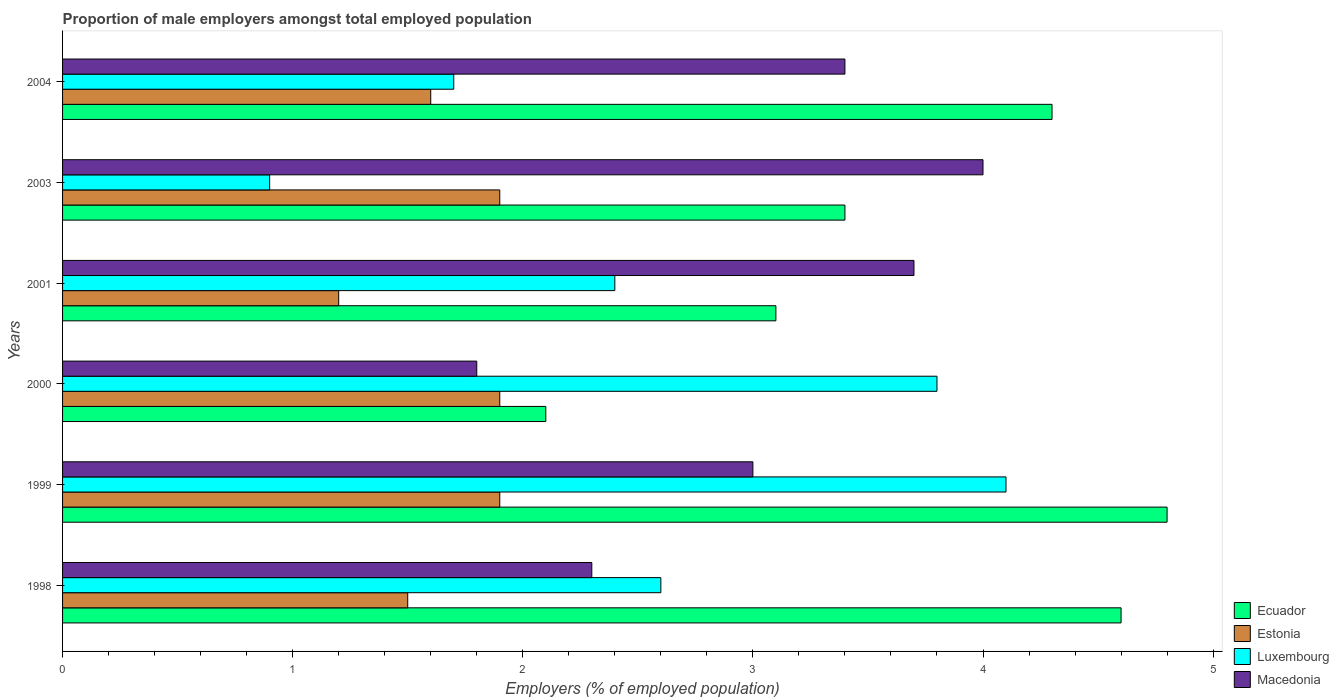How many different coloured bars are there?
Keep it short and to the point. 4. Are the number of bars per tick equal to the number of legend labels?
Provide a succinct answer. Yes. How many bars are there on the 3rd tick from the bottom?
Ensure brevity in your answer.  4. What is the label of the 4th group of bars from the top?
Make the answer very short. 2000. In how many cases, is the number of bars for a given year not equal to the number of legend labels?
Offer a very short reply. 0. What is the proportion of male employers in Estonia in 2001?
Ensure brevity in your answer.  1.2. Across all years, what is the maximum proportion of male employers in Ecuador?
Your answer should be compact. 4.8. Across all years, what is the minimum proportion of male employers in Ecuador?
Keep it short and to the point. 2.1. In which year was the proportion of male employers in Ecuador minimum?
Keep it short and to the point. 2000. What is the total proportion of male employers in Macedonia in the graph?
Offer a terse response. 18.2. What is the difference between the proportion of male employers in Ecuador in 2003 and that in 2004?
Offer a very short reply. -0.9. What is the difference between the proportion of male employers in Ecuador in 2004 and the proportion of male employers in Estonia in 1999?
Make the answer very short. 2.4. What is the average proportion of male employers in Luxembourg per year?
Offer a terse response. 2.58. In the year 2003, what is the difference between the proportion of male employers in Ecuador and proportion of male employers in Luxembourg?
Keep it short and to the point. 2.5. What is the ratio of the proportion of male employers in Ecuador in 1999 to that in 2001?
Your response must be concise. 1.55. Is the proportion of male employers in Ecuador in 1999 less than that in 2003?
Keep it short and to the point. No. What is the difference between the highest and the second highest proportion of male employers in Macedonia?
Ensure brevity in your answer.  0.3. What is the difference between the highest and the lowest proportion of male employers in Luxembourg?
Provide a succinct answer. 3.2. In how many years, is the proportion of male employers in Ecuador greater than the average proportion of male employers in Ecuador taken over all years?
Your answer should be compact. 3. Is the sum of the proportion of male employers in Ecuador in 1998 and 2003 greater than the maximum proportion of male employers in Estonia across all years?
Your response must be concise. Yes. What does the 2nd bar from the top in 2001 represents?
Make the answer very short. Luxembourg. What does the 1st bar from the bottom in 1999 represents?
Make the answer very short. Ecuador. Is it the case that in every year, the sum of the proportion of male employers in Estonia and proportion of male employers in Ecuador is greater than the proportion of male employers in Macedonia?
Give a very brief answer. Yes. How many bars are there?
Ensure brevity in your answer.  24. Are all the bars in the graph horizontal?
Make the answer very short. Yes. How many years are there in the graph?
Your response must be concise. 6. Are the values on the major ticks of X-axis written in scientific E-notation?
Make the answer very short. No. Does the graph contain grids?
Offer a terse response. No. What is the title of the graph?
Ensure brevity in your answer.  Proportion of male employers amongst total employed population. Does "Sint Maarten (Dutch part)" appear as one of the legend labels in the graph?
Make the answer very short. No. What is the label or title of the X-axis?
Your answer should be compact. Employers (% of employed population). What is the label or title of the Y-axis?
Your answer should be very brief. Years. What is the Employers (% of employed population) of Ecuador in 1998?
Make the answer very short. 4.6. What is the Employers (% of employed population) in Luxembourg in 1998?
Your answer should be very brief. 2.6. What is the Employers (% of employed population) of Macedonia in 1998?
Offer a terse response. 2.3. What is the Employers (% of employed population) in Ecuador in 1999?
Make the answer very short. 4.8. What is the Employers (% of employed population) of Estonia in 1999?
Offer a very short reply. 1.9. What is the Employers (% of employed population) of Luxembourg in 1999?
Provide a succinct answer. 4.1. What is the Employers (% of employed population) of Macedonia in 1999?
Your answer should be very brief. 3. What is the Employers (% of employed population) of Ecuador in 2000?
Your answer should be very brief. 2.1. What is the Employers (% of employed population) of Estonia in 2000?
Provide a succinct answer. 1.9. What is the Employers (% of employed population) of Luxembourg in 2000?
Your answer should be very brief. 3.8. What is the Employers (% of employed population) in Macedonia in 2000?
Give a very brief answer. 1.8. What is the Employers (% of employed population) of Ecuador in 2001?
Give a very brief answer. 3.1. What is the Employers (% of employed population) of Estonia in 2001?
Ensure brevity in your answer.  1.2. What is the Employers (% of employed population) in Luxembourg in 2001?
Your response must be concise. 2.4. What is the Employers (% of employed population) of Macedonia in 2001?
Offer a very short reply. 3.7. What is the Employers (% of employed population) in Ecuador in 2003?
Keep it short and to the point. 3.4. What is the Employers (% of employed population) in Estonia in 2003?
Offer a very short reply. 1.9. What is the Employers (% of employed population) of Luxembourg in 2003?
Offer a terse response. 0.9. What is the Employers (% of employed population) of Macedonia in 2003?
Ensure brevity in your answer.  4. What is the Employers (% of employed population) in Ecuador in 2004?
Provide a succinct answer. 4.3. What is the Employers (% of employed population) of Estonia in 2004?
Keep it short and to the point. 1.6. What is the Employers (% of employed population) of Luxembourg in 2004?
Your response must be concise. 1.7. What is the Employers (% of employed population) in Macedonia in 2004?
Ensure brevity in your answer.  3.4. Across all years, what is the maximum Employers (% of employed population) of Ecuador?
Offer a terse response. 4.8. Across all years, what is the maximum Employers (% of employed population) in Estonia?
Provide a succinct answer. 1.9. Across all years, what is the maximum Employers (% of employed population) of Luxembourg?
Your answer should be compact. 4.1. Across all years, what is the maximum Employers (% of employed population) of Macedonia?
Keep it short and to the point. 4. Across all years, what is the minimum Employers (% of employed population) of Ecuador?
Your answer should be very brief. 2.1. Across all years, what is the minimum Employers (% of employed population) of Estonia?
Give a very brief answer. 1.2. Across all years, what is the minimum Employers (% of employed population) in Luxembourg?
Make the answer very short. 0.9. Across all years, what is the minimum Employers (% of employed population) in Macedonia?
Make the answer very short. 1.8. What is the total Employers (% of employed population) of Ecuador in the graph?
Your response must be concise. 22.3. What is the total Employers (% of employed population) in Estonia in the graph?
Keep it short and to the point. 10. What is the total Employers (% of employed population) of Macedonia in the graph?
Your answer should be very brief. 18.2. What is the difference between the Employers (% of employed population) in Estonia in 1998 and that in 1999?
Your answer should be very brief. -0.4. What is the difference between the Employers (% of employed population) of Luxembourg in 1998 and that in 1999?
Offer a terse response. -1.5. What is the difference between the Employers (% of employed population) in Macedonia in 1998 and that in 1999?
Give a very brief answer. -0.7. What is the difference between the Employers (% of employed population) in Ecuador in 1998 and that in 2000?
Provide a succinct answer. 2.5. What is the difference between the Employers (% of employed population) of Ecuador in 1998 and that in 2001?
Ensure brevity in your answer.  1.5. What is the difference between the Employers (% of employed population) in Estonia in 1998 and that in 2001?
Your answer should be compact. 0.3. What is the difference between the Employers (% of employed population) in Luxembourg in 1998 and that in 2001?
Your response must be concise. 0.2. What is the difference between the Employers (% of employed population) of Ecuador in 1998 and that in 2003?
Your response must be concise. 1.2. What is the difference between the Employers (% of employed population) of Estonia in 1998 and that in 2003?
Keep it short and to the point. -0.4. What is the difference between the Employers (% of employed population) of Luxembourg in 1998 and that in 2003?
Offer a terse response. 1.7. What is the difference between the Employers (% of employed population) of Macedonia in 1998 and that in 2003?
Provide a succinct answer. -1.7. What is the difference between the Employers (% of employed population) in Luxembourg in 1998 and that in 2004?
Keep it short and to the point. 0.9. What is the difference between the Employers (% of employed population) of Estonia in 1999 and that in 2000?
Make the answer very short. 0. What is the difference between the Employers (% of employed population) of Macedonia in 1999 and that in 2000?
Ensure brevity in your answer.  1.2. What is the difference between the Employers (% of employed population) in Ecuador in 1999 and that in 2001?
Ensure brevity in your answer.  1.7. What is the difference between the Employers (% of employed population) in Luxembourg in 1999 and that in 2001?
Give a very brief answer. 1.7. What is the difference between the Employers (% of employed population) in Macedonia in 1999 and that in 2001?
Give a very brief answer. -0.7. What is the difference between the Employers (% of employed population) of Ecuador in 1999 and that in 2003?
Keep it short and to the point. 1.4. What is the difference between the Employers (% of employed population) in Macedonia in 1999 and that in 2003?
Ensure brevity in your answer.  -1. What is the difference between the Employers (% of employed population) of Ecuador in 1999 and that in 2004?
Your answer should be compact. 0.5. What is the difference between the Employers (% of employed population) of Macedonia in 2000 and that in 2001?
Offer a very short reply. -1.9. What is the difference between the Employers (% of employed population) of Ecuador in 2000 and that in 2003?
Your answer should be compact. -1.3. What is the difference between the Employers (% of employed population) of Luxembourg in 2000 and that in 2003?
Give a very brief answer. 2.9. What is the difference between the Employers (% of employed population) in Macedonia in 2000 and that in 2003?
Keep it short and to the point. -2.2. What is the difference between the Employers (% of employed population) of Ecuador in 2000 and that in 2004?
Provide a succinct answer. -2.2. What is the difference between the Employers (% of employed population) in Luxembourg in 2000 and that in 2004?
Provide a short and direct response. 2.1. What is the difference between the Employers (% of employed population) in Macedonia in 2000 and that in 2004?
Keep it short and to the point. -1.6. What is the difference between the Employers (% of employed population) in Macedonia in 2001 and that in 2003?
Provide a short and direct response. -0.3. What is the difference between the Employers (% of employed population) in Ecuador in 2001 and that in 2004?
Your answer should be very brief. -1.2. What is the difference between the Employers (% of employed population) in Macedonia in 2001 and that in 2004?
Make the answer very short. 0.3. What is the difference between the Employers (% of employed population) in Luxembourg in 2003 and that in 2004?
Your answer should be compact. -0.8. What is the difference between the Employers (% of employed population) in Macedonia in 2003 and that in 2004?
Give a very brief answer. 0.6. What is the difference between the Employers (% of employed population) in Ecuador in 1998 and the Employers (% of employed population) in Luxembourg in 1999?
Give a very brief answer. 0.5. What is the difference between the Employers (% of employed population) of Ecuador in 1998 and the Employers (% of employed population) of Macedonia in 1999?
Provide a succinct answer. 1.6. What is the difference between the Employers (% of employed population) of Estonia in 1998 and the Employers (% of employed population) of Luxembourg in 2000?
Your answer should be very brief. -2.3. What is the difference between the Employers (% of employed population) in Ecuador in 1998 and the Employers (% of employed population) in Estonia in 2001?
Your response must be concise. 3.4. What is the difference between the Employers (% of employed population) of Ecuador in 1998 and the Employers (% of employed population) of Macedonia in 2001?
Offer a very short reply. 0.9. What is the difference between the Employers (% of employed population) in Estonia in 1998 and the Employers (% of employed population) in Macedonia in 2001?
Your response must be concise. -2.2. What is the difference between the Employers (% of employed population) in Luxembourg in 1998 and the Employers (% of employed population) in Macedonia in 2001?
Your response must be concise. -1.1. What is the difference between the Employers (% of employed population) in Ecuador in 1998 and the Employers (% of employed population) in Estonia in 2003?
Give a very brief answer. 2.7. What is the difference between the Employers (% of employed population) of Ecuador in 1998 and the Employers (% of employed population) of Luxembourg in 2003?
Make the answer very short. 3.7. What is the difference between the Employers (% of employed population) of Ecuador in 1998 and the Employers (% of employed population) of Macedonia in 2003?
Give a very brief answer. 0.6. What is the difference between the Employers (% of employed population) in Estonia in 1998 and the Employers (% of employed population) in Luxembourg in 2003?
Your answer should be compact. 0.6. What is the difference between the Employers (% of employed population) of Estonia in 1998 and the Employers (% of employed population) of Macedonia in 2003?
Provide a short and direct response. -2.5. What is the difference between the Employers (% of employed population) in Luxembourg in 1998 and the Employers (% of employed population) in Macedonia in 2003?
Make the answer very short. -1.4. What is the difference between the Employers (% of employed population) of Ecuador in 1998 and the Employers (% of employed population) of Estonia in 2004?
Provide a short and direct response. 3. What is the difference between the Employers (% of employed population) of Ecuador in 1998 and the Employers (% of employed population) of Luxembourg in 2004?
Your answer should be very brief. 2.9. What is the difference between the Employers (% of employed population) in Ecuador in 1999 and the Employers (% of employed population) in Estonia in 2000?
Offer a terse response. 2.9. What is the difference between the Employers (% of employed population) in Ecuador in 1999 and the Employers (% of employed population) in Macedonia in 2000?
Keep it short and to the point. 3. What is the difference between the Employers (% of employed population) in Ecuador in 1999 and the Employers (% of employed population) in Luxembourg in 2001?
Ensure brevity in your answer.  2.4. What is the difference between the Employers (% of employed population) of Ecuador in 1999 and the Employers (% of employed population) of Macedonia in 2003?
Provide a succinct answer. 0.8. What is the difference between the Employers (% of employed population) in Estonia in 1999 and the Employers (% of employed population) in Luxembourg in 2003?
Offer a terse response. 1. What is the difference between the Employers (% of employed population) of Estonia in 1999 and the Employers (% of employed population) of Macedonia in 2003?
Provide a succinct answer. -2.1. What is the difference between the Employers (% of employed population) of Ecuador in 1999 and the Employers (% of employed population) of Estonia in 2004?
Provide a succinct answer. 3.2. What is the difference between the Employers (% of employed population) in Ecuador in 1999 and the Employers (% of employed population) in Macedonia in 2004?
Ensure brevity in your answer.  1.4. What is the difference between the Employers (% of employed population) of Estonia in 1999 and the Employers (% of employed population) of Macedonia in 2004?
Offer a very short reply. -1.5. What is the difference between the Employers (% of employed population) in Luxembourg in 1999 and the Employers (% of employed population) in Macedonia in 2004?
Keep it short and to the point. 0.7. What is the difference between the Employers (% of employed population) in Ecuador in 2000 and the Employers (% of employed population) in Estonia in 2001?
Offer a very short reply. 0.9. What is the difference between the Employers (% of employed population) of Ecuador in 2000 and the Employers (% of employed population) of Macedonia in 2001?
Your answer should be compact. -1.6. What is the difference between the Employers (% of employed population) in Estonia in 2000 and the Employers (% of employed population) in Luxembourg in 2001?
Keep it short and to the point. -0.5. What is the difference between the Employers (% of employed population) of Estonia in 2000 and the Employers (% of employed population) of Macedonia in 2001?
Your answer should be very brief. -1.8. What is the difference between the Employers (% of employed population) of Ecuador in 2000 and the Employers (% of employed population) of Luxembourg in 2003?
Provide a succinct answer. 1.2. What is the difference between the Employers (% of employed population) of Ecuador in 2000 and the Employers (% of employed population) of Macedonia in 2003?
Make the answer very short. -1.9. What is the difference between the Employers (% of employed population) of Estonia in 2000 and the Employers (% of employed population) of Luxembourg in 2003?
Make the answer very short. 1. What is the difference between the Employers (% of employed population) of Estonia in 2000 and the Employers (% of employed population) of Macedonia in 2003?
Provide a short and direct response. -2.1. What is the difference between the Employers (% of employed population) of Luxembourg in 2000 and the Employers (% of employed population) of Macedonia in 2003?
Offer a terse response. -0.2. What is the difference between the Employers (% of employed population) of Ecuador in 2000 and the Employers (% of employed population) of Estonia in 2004?
Ensure brevity in your answer.  0.5. What is the difference between the Employers (% of employed population) of Ecuador in 2000 and the Employers (% of employed population) of Luxembourg in 2004?
Give a very brief answer. 0.4. What is the difference between the Employers (% of employed population) in Estonia in 2000 and the Employers (% of employed population) in Luxembourg in 2004?
Keep it short and to the point. 0.2. What is the difference between the Employers (% of employed population) in Ecuador in 2001 and the Employers (% of employed population) in Estonia in 2003?
Your answer should be very brief. 1.2. What is the difference between the Employers (% of employed population) in Ecuador in 2001 and the Employers (% of employed population) in Luxembourg in 2003?
Provide a short and direct response. 2.2. What is the difference between the Employers (% of employed population) of Ecuador in 2001 and the Employers (% of employed population) of Macedonia in 2003?
Your answer should be very brief. -0.9. What is the difference between the Employers (% of employed population) of Estonia in 2001 and the Employers (% of employed population) of Luxembourg in 2003?
Your answer should be compact. 0.3. What is the difference between the Employers (% of employed population) of Estonia in 2001 and the Employers (% of employed population) of Macedonia in 2003?
Offer a terse response. -2.8. What is the difference between the Employers (% of employed population) in Ecuador in 2001 and the Employers (% of employed population) in Luxembourg in 2004?
Make the answer very short. 1.4. What is the difference between the Employers (% of employed population) of Estonia in 2001 and the Employers (% of employed population) of Luxembourg in 2004?
Offer a terse response. -0.5. What is the difference between the Employers (% of employed population) of Ecuador in 2003 and the Employers (% of employed population) of Luxembourg in 2004?
Make the answer very short. 1.7. What is the difference between the Employers (% of employed population) in Estonia in 2003 and the Employers (% of employed population) in Macedonia in 2004?
Make the answer very short. -1.5. What is the average Employers (% of employed population) of Ecuador per year?
Make the answer very short. 3.72. What is the average Employers (% of employed population) in Estonia per year?
Offer a very short reply. 1.67. What is the average Employers (% of employed population) in Luxembourg per year?
Your response must be concise. 2.58. What is the average Employers (% of employed population) in Macedonia per year?
Your response must be concise. 3.03. In the year 1998, what is the difference between the Employers (% of employed population) in Ecuador and Employers (% of employed population) in Estonia?
Your answer should be very brief. 3.1. In the year 1998, what is the difference between the Employers (% of employed population) of Luxembourg and Employers (% of employed population) of Macedonia?
Ensure brevity in your answer.  0.3. In the year 1999, what is the difference between the Employers (% of employed population) in Ecuador and Employers (% of employed population) in Macedonia?
Give a very brief answer. 1.8. In the year 1999, what is the difference between the Employers (% of employed population) of Estonia and Employers (% of employed population) of Macedonia?
Offer a terse response. -1.1. In the year 2000, what is the difference between the Employers (% of employed population) of Ecuador and Employers (% of employed population) of Estonia?
Offer a terse response. 0.2. In the year 2000, what is the difference between the Employers (% of employed population) in Ecuador and Employers (% of employed population) in Luxembourg?
Offer a terse response. -1.7. In the year 2000, what is the difference between the Employers (% of employed population) in Estonia and Employers (% of employed population) in Macedonia?
Keep it short and to the point. 0.1. In the year 2000, what is the difference between the Employers (% of employed population) of Luxembourg and Employers (% of employed population) of Macedonia?
Ensure brevity in your answer.  2. In the year 2001, what is the difference between the Employers (% of employed population) in Ecuador and Employers (% of employed population) in Luxembourg?
Provide a succinct answer. 0.7. In the year 2001, what is the difference between the Employers (% of employed population) of Estonia and Employers (% of employed population) of Macedonia?
Offer a terse response. -2.5. In the year 2003, what is the difference between the Employers (% of employed population) of Ecuador and Employers (% of employed population) of Estonia?
Offer a terse response. 1.5. In the year 2003, what is the difference between the Employers (% of employed population) in Estonia and Employers (% of employed population) in Macedonia?
Your answer should be very brief. -2.1. In the year 2004, what is the difference between the Employers (% of employed population) in Ecuador and Employers (% of employed population) in Estonia?
Keep it short and to the point. 2.7. In the year 2004, what is the difference between the Employers (% of employed population) in Ecuador and Employers (% of employed population) in Luxembourg?
Make the answer very short. 2.6. In the year 2004, what is the difference between the Employers (% of employed population) in Ecuador and Employers (% of employed population) in Macedonia?
Ensure brevity in your answer.  0.9. In the year 2004, what is the difference between the Employers (% of employed population) in Estonia and Employers (% of employed population) in Luxembourg?
Make the answer very short. -0.1. In the year 2004, what is the difference between the Employers (% of employed population) in Luxembourg and Employers (% of employed population) in Macedonia?
Ensure brevity in your answer.  -1.7. What is the ratio of the Employers (% of employed population) of Estonia in 1998 to that in 1999?
Offer a terse response. 0.79. What is the ratio of the Employers (% of employed population) in Luxembourg in 1998 to that in 1999?
Provide a short and direct response. 0.63. What is the ratio of the Employers (% of employed population) in Macedonia in 1998 to that in 1999?
Your response must be concise. 0.77. What is the ratio of the Employers (% of employed population) of Ecuador in 1998 to that in 2000?
Your answer should be compact. 2.19. What is the ratio of the Employers (% of employed population) in Estonia in 1998 to that in 2000?
Ensure brevity in your answer.  0.79. What is the ratio of the Employers (% of employed population) in Luxembourg in 1998 to that in 2000?
Keep it short and to the point. 0.68. What is the ratio of the Employers (% of employed population) in Macedonia in 1998 to that in 2000?
Offer a very short reply. 1.28. What is the ratio of the Employers (% of employed population) in Ecuador in 1998 to that in 2001?
Your answer should be very brief. 1.48. What is the ratio of the Employers (% of employed population) in Macedonia in 1998 to that in 2001?
Your answer should be compact. 0.62. What is the ratio of the Employers (% of employed population) in Ecuador in 1998 to that in 2003?
Provide a succinct answer. 1.35. What is the ratio of the Employers (% of employed population) of Estonia in 1998 to that in 2003?
Provide a succinct answer. 0.79. What is the ratio of the Employers (% of employed population) in Luxembourg in 1998 to that in 2003?
Keep it short and to the point. 2.89. What is the ratio of the Employers (% of employed population) in Macedonia in 1998 to that in 2003?
Ensure brevity in your answer.  0.57. What is the ratio of the Employers (% of employed population) in Ecuador in 1998 to that in 2004?
Your answer should be very brief. 1.07. What is the ratio of the Employers (% of employed population) of Luxembourg in 1998 to that in 2004?
Provide a short and direct response. 1.53. What is the ratio of the Employers (% of employed population) in Macedonia in 1998 to that in 2004?
Offer a terse response. 0.68. What is the ratio of the Employers (% of employed population) of Ecuador in 1999 to that in 2000?
Your answer should be compact. 2.29. What is the ratio of the Employers (% of employed population) in Estonia in 1999 to that in 2000?
Make the answer very short. 1. What is the ratio of the Employers (% of employed population) of Luxembourg in 1999 to that in 2000?
Provide a succinct answer. 1.08. What is the ratio of the Employers (% of employed population) in Macedonia in 1999 to that in 2000?
Give a very brief answer. 1.67. What is the ratio of the Employers (% of employed population) in Ecuador in 1999 to that in 2001?
Ensure brevity in your answer.  1.55. What is the ratio of the Employers (% of employed population) in Estonia in 1999 to that in 2001?
Ensure brevity in your answer.  1.58. What is the ratio of the Employers (% of employed population) of Luxembourg in 1999 to that in 2001?
Your answer should be very brief. 1.71. What is the ratio of the Employers (% of employed population) of Macedonia in 1999 to that in 2001?
Provide a short and direct response. 0.81. What is the ratio of the Employers (% of employed population) in Ecuador in 1999 to that in 2003?
Ensure brevity in your answer.  1.41. What is the ratio of the Employers (% of employed population) in Luxembourg in 1999 to that in 2003?
Ensure brevity in your answer.  4.56. What is the ratio of the Employers (% of employed population) of Macedonia in 1999 to that in 2003?
Your answer should be compact. 0.75. What is the ratio of the Employers (% of employed population) in Ecuador in 1999 to that in 2004?
Keep it short and to the point. 1.12. What is the ratio of the Employers (% of employed population) in Estonia in 1999 to that in 2004?
Offer a very short reply. 1.19. What is the ratio of the Employers (% of employed population) of Luxembourg in 1999 to that in 2004?
Your answer should be very brief. 2.41. What is the ratio of the Employers (% of employed population) in Macedonia in 1999 to that in 2004?
Your response must be concise. 0.88. What is the ratio of the Employers (% of employed population) in Ecuador in 2000 to that in 2001?
Offer a terse response. 0.68. What is the ratio of the Employers (% of employed population) of Estonia in 2000 to that in 2001?
Provide a short and direct response. 1.58. What is the ratio of the Employers (% of employed population) in Luxembourg in 2000 to that in 2001?
Ensure brevity in your answer.  1.58. What is the ratio of the Employers (% of employed population) in Macedonia in 2000 to that in 2001?
Your answer should be compact. 0.49. What is the ratio of the Employers (% of employed population) in Ecuador in 2000 to that in 2003?
Provide a succinct answer. 0.62. What is the ratio of the Employers (% of employed population) in Luxembourg in 2000 to that in 2003?
Keep it short and to the point. 4.22. What is the ratio of the Employers (% of employed population) of Macedonia in 2000 to that in 2003?
Your answer should be compact. 0.45. What is the ratio of the Employers (% of employed population) of Ecuador in 2000 to that in 2004?
Offer a terse response. 0.49. What is the ratio of the Employers (% of employed population) in Estonia in 2000 to that in 2004?
Offer a very short reply. 1.19. What is the ratio of the Employers (% of employed population) of Luxembourg in 2000 to that in 2004?
Provide a short and direct response. 2.24. What is the ratio of the Employers (% of employed population) of Macedonia in 2000 to that in 2004?
Provide a succinct answer. 0.53. What is the ratio of the Employers (% of employed population) of Ecuador in 2001 to that in 2003?
Make the answer very short. 0.91. What is the ratio of the Employers (% of employed population) of Estonia in 2001 to that in 2003?
Make the answer very short. 0.63. What is the ratio of the Employers (% of employed population) of Luxembourg in 2001 to that in 2003?
Provide a short and direct response. 2.67. What is the ratio of the Employers (% of employed population) of Macedonia in 2001 to that in 2003?
Provide a short and direct response. 0.93. What is the ratio of the Employers (% of employed population) in Ecuador in 2001 to that in 2004?
Keep it short and to the point. 0.72. What is the ratio of the Employers (% of employed population) of Estonia in 2001 to that in 2004?
Make the answer very short. 0.75. What is the ratio of the Employers (% of employed population) of Luxembourg in 2001 to that in 2004?
Your answer should be very brief. 1.41. What is the ratio of the Employers (% of employed population) in Macedonia in 2001 to that in 2004?
Keep it short and to the point. 1.09. What is the ratio of the Employers (% of employed population) in Ecuador in 2003 to that in 2004?
Make the answer very short. 0.79. What is the ratio of the Employers (% of employed population) in Estonia in 2003 to that in 2004?
Your answer should be compact. 1.19. What is the ratio of the Employers (% of employed population) of Luxembourg in 2003 to that in 2004?
Keep it short and to the point. 0.53. What is the ratio of the Employers (% of employed population) in Macedonia in 2003 to that in 2004?
Keep it short and to the point. 1.18. What is the difference between the highest and the second highest Employers (% of employed population) in Macedonia?
Provide a short and direct response. 0.3. What is the difference between the highest and the lowest Employers (% of employed population) in Luxembourg?
Provide a short and direct response. 3.2. 